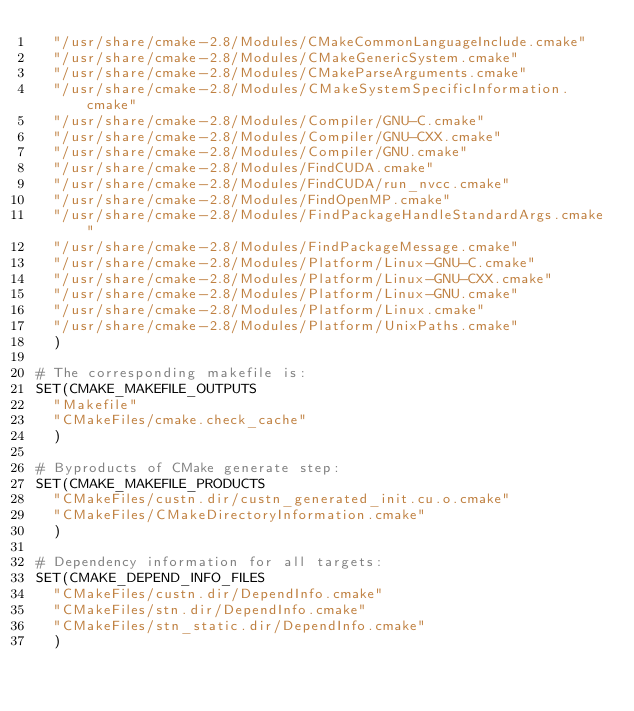Convert code to text. <code><loc_0><loc_0><loc_500><loc_500><_CMake_>  "/usr/share/cmake-2.8/Modules/CMakeCommonLanguageInclude.cmake"
  "/usr/share/cmake-2.8/Modules/CMakeGenericSystem.cmake"
  "/usr/share/cmake-2.8/Modules/CMakeParseArguments.cmake"
  "/usr/share/cmake-2.8/Modules/CMakeSystemSpecificInformation.cmake"
  "/usr/share/cmake-2.8/Modules/Compiler/GNU-C.cmake"
  "/usr/share/cmake-2.8/Modules/Compiler/GNU-CXX.cmake"
  "/usr/share/cmake-2.8/Modules/Compiler/GNU.cmake"
  "/usr/share/cmake-2.8/Modules/FindCUDA.cmake"
  "/usr/share/cmake-2.8/Modules/FindCUDA/run_nvcc.cmake"
  "/usr/share/cmake-2.8/Modules/FindOpenMP.cmake"
  "/usr/share/cmake-2.8/Modules/FindPackageHandleStandardArgs.cmake"
  "/usr/share/cmake-2.8/Modules/FindPackageMessage.cmake"
  "/usr/share/cmake-2.8/Modules/Platform/Linux-GNU-C.cmake"
  "/usr/share/cmake-2.8/Modules/Platform/Linux-GNU-CXX.cmake"
  "/usr/share/cmake-2.8/Modules/Platform/Linux-GNU.cmake"
  "/usr/share/cmake-2.8/Modules/Platform/Linux.cmake"
  "/usr/share/cmake-2.8/Modules/Platform/UnixPaths.cmake"
  )

# The corresponding makefile is:
SET(CMAKE_MAKEFILE_OUTPUTS
  "Makefile"
  "CMakeFiles/cmake.check_cache"
  )

# Byproducts of CMake generate step:
SET(CMAKE_MAKEFILE_PRODUCTS
  "CMakeFiles/custn.dir/custn_generated_init.cu.o.cmake"
  "CMakeFiles/CMakeDirectoryInformation.cmake"
  )

# Dependency information for all targets:
SET(CMAKE_DEPEND_INFO_FILES
  "CMakeFiles/custn.dir/DependInfo.cmake"
  "CMakeFiles/stn.dir/DependInfo.cmake"
  "CMakeFiles/stn_static.dir/DependInfo.cmake"
  )
</code> 